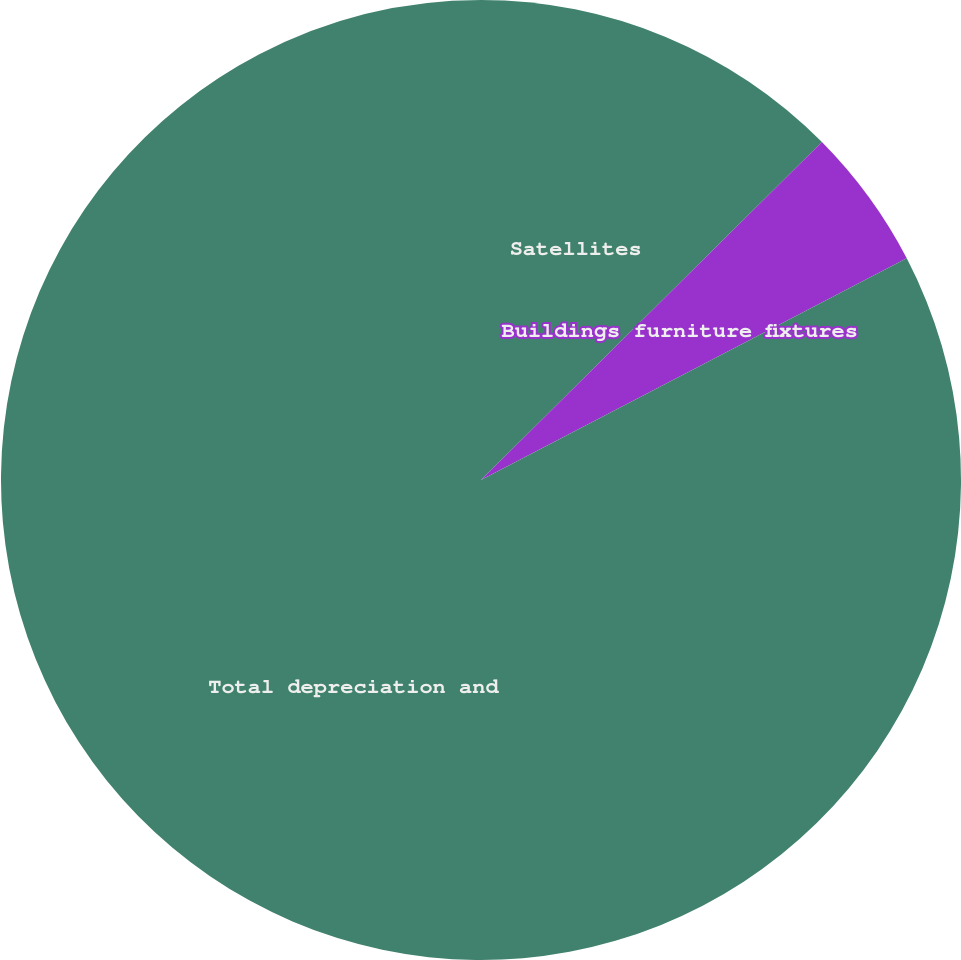Convert chart. <chart><loc_0><loc_0><loc_500><loc_500><pie_chart><fcel>Satellites<fcel>Buildings furniture fixtures<fcel>Total depreciation and<nl><fcel>12.57%<fcel>4.79%<fcel>82.64%<nl></chart> 